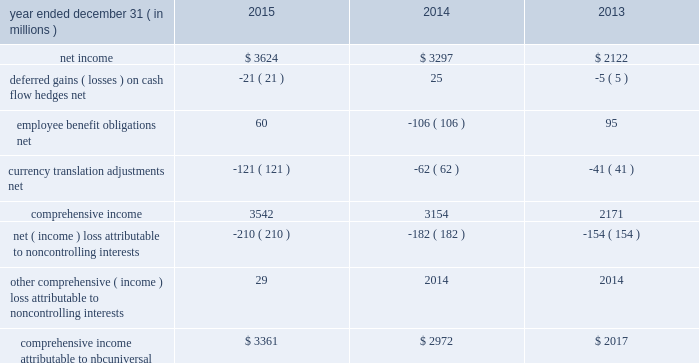Nbcuniversal media , llc consolidated statement of comprehensive income .
See accompanying notes to consolidated financial statements .
147 comcast 2015 annual report on form 10-k .
What was the average net income from 2013 to 2015? 
Computations: (((2122 + (3624 + 3297)) + 3) / 2)
Answer: 4523.0. 